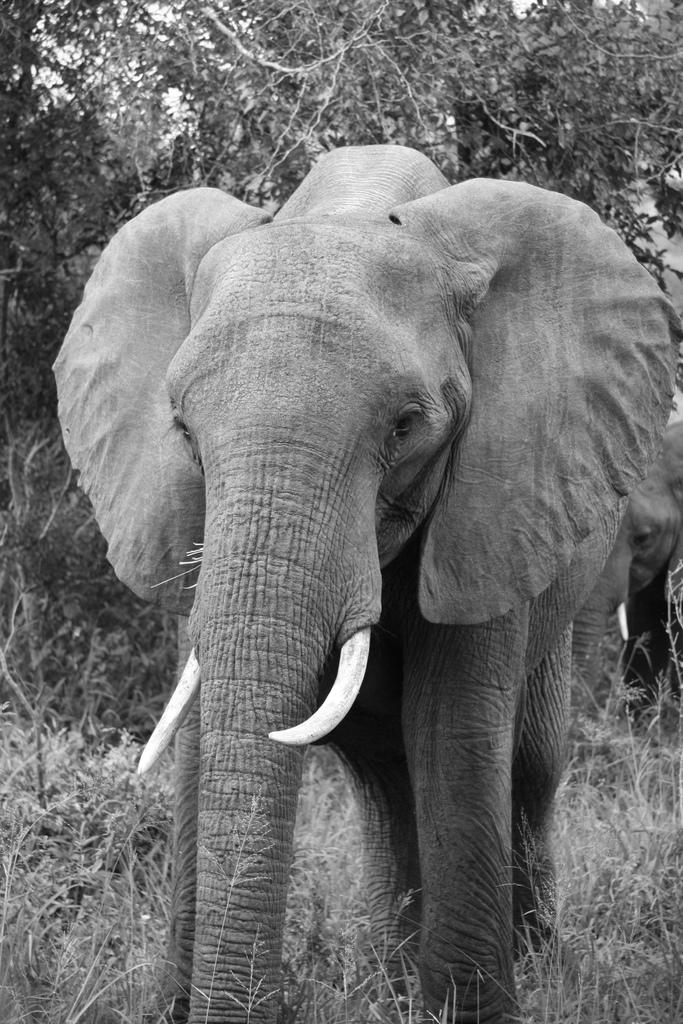What is the color scheme of the image? The image is black and white. What animal can be seen in the image? There is an elephant in the image. What type of terrain is the elephant standing on? The elephant is standing on grassy land. What can be seen in the background behind the elephant? Trees are visible behind the elephant. What type of school can be seen in the image? There is no school present in the image; it features an elephant standing on grassy land with trees in the background. How many hands does the elephant have in the image? Elephants do not have hands; they have feet and a trunk. In the image, the elephant has four feet and a trunk. 